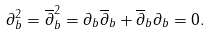<formula> <loc_0><loc_0><loc_500><loc_500>\partial _ { b } ^ { 2 } = \overline { \partial } _ { b } ^ { 2 } = \partial _ { b } \overline { \partial } _ { b } + \overline { \partial } _ { b } \partial _ { b } = 0 .</formula> 